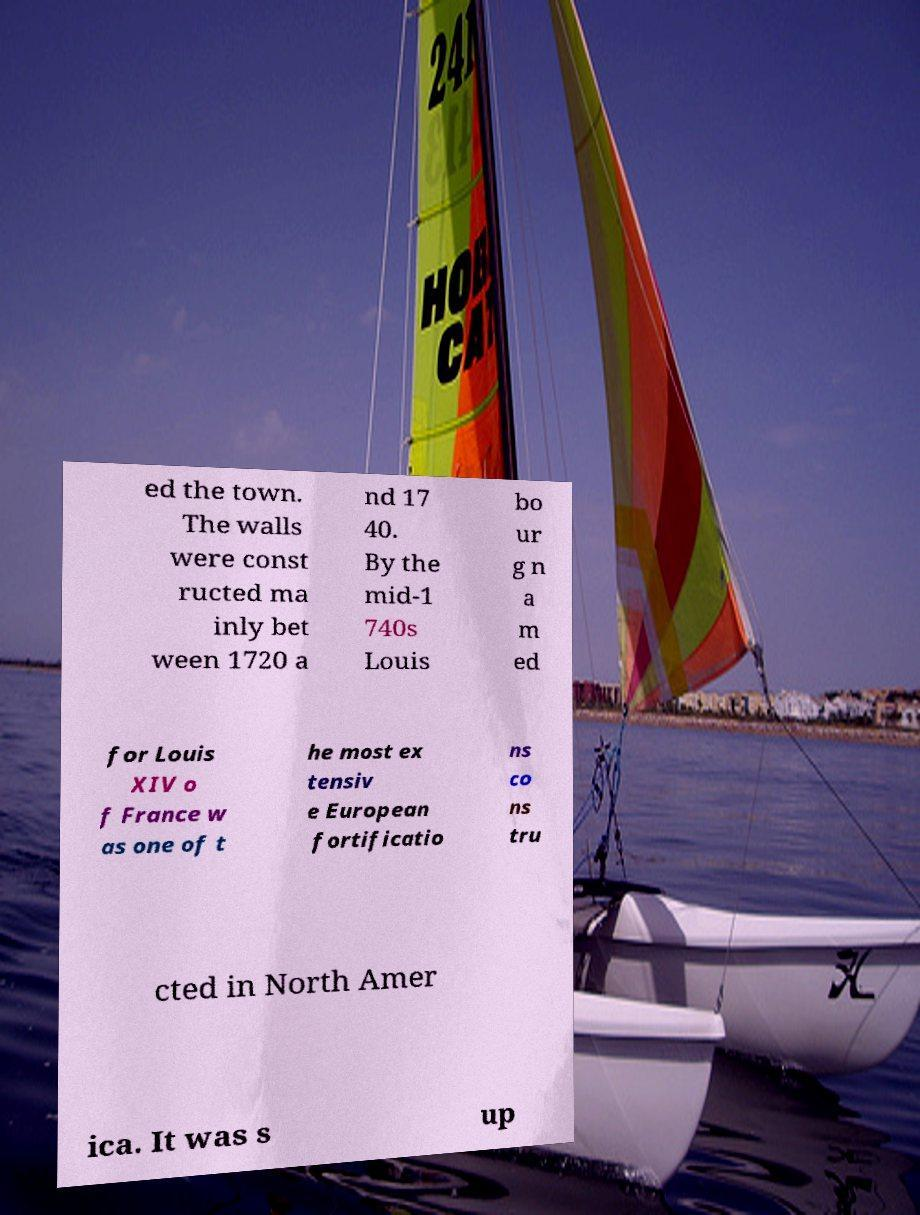Please identify and transcribe the text found in this image. ed the town. The walls were const ructed ma inly bet ween 1720 a nd 17 40. By the mid-1 740s Louis bo ur g n a m ed for Louis XIV o f France w as one of t he most ex tensiv e European fortificatio ns co ns tru cted in North Amer ica. It was s up 